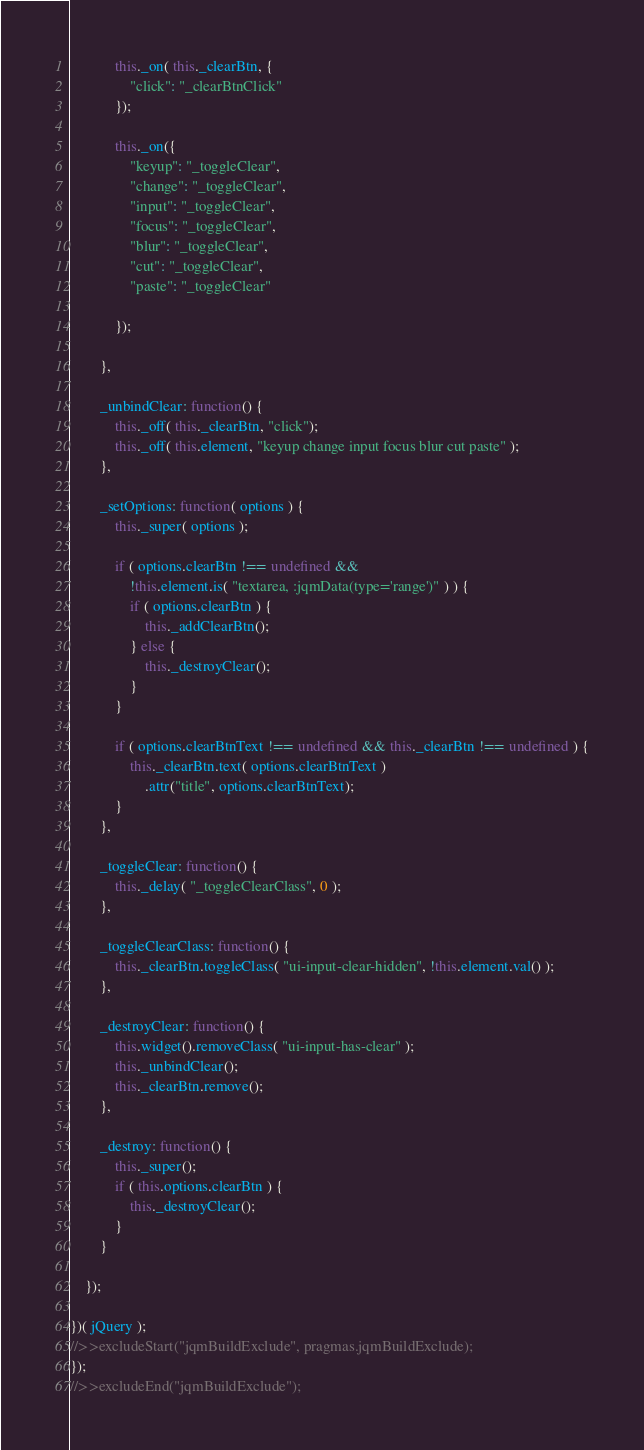Convert code to text. <code><loc_0><loc_0><loc_500><loc_500><_JavaScript_>
			this._on( this._clearBtn, {
				"click": "_clearBtnClick"
			});

			this._on({
				"keyup": "_toggleClear",
				"change": "_toggleClear",
				"input": "_toggleClear",
				"focus": "_toggleClear",
				"blur": "_toggleClear",
				"cut": "_toggleClear",
				"paste": "_toggleClear"

			});

		},

		_unbindClear: function() {
			this._off( this._clearBtn, "click");
			this._off( this.element, "keyup change input focus blur cut paste" );
		},

		_setOptions: function( options ) {
			this._super( options );

			if ( options.clearBtn !== undefined &&
				!this.element.is( "textarea, :jqmData(type='range')" ) ) {
				if ( options.clearBtn ) {
					this._addClearBtn();
				} else {
					this._destroyClear();
				}
			}

			if ( options.clearBtnText !== undefined && this._clearBtn !== undefined ) {
				this._clearBtn.text( options.clearBtnText )
					.attr("title", options.clearBtnText);
			}
		},

		_toggleClear: function() {
			this._delay( "_toggleClearClass", 0 );
		},

		_toggleClearClass: function() {
			this._clearBtn.toggleClass( "ui-input-clear-hidden", !this.element.val() );
		},

		_destroyClear: function() {
			this.widget().removeClass( "ui-input-has-clear" );
			this._unbindClear();
			this._clearBtn.remove();
		},

		_destroy: function() {
			this._super();
			if ( this.options.clearBtn ) {
				this._destroyClear();
			}
		}

	});

})( jQuery );
//>>excludeStart("jqmBuildExclude", pragmas.jqmBuildExclude);
});
//>>excludeEnd("jqmBuildExclude");
</code> 